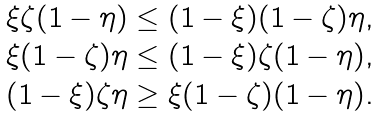Convert formula to latex. <formula><loc_0><loc_0><loc_500><loc_500>\begin{array} { l } \xi \zeta ( 1 - \eta ) \leq ( 1 - \xi ) ( 1 - \zeta ) \eta , \\ \xi ( 1 - \zeta ) \eta \leq ( 1 - \xi ) \zeta ( 1 - \eta ) , \\ ( 1 - \xi ) \zeta \eta \geq \xi ( 1 - \zeta ) ( 1 - \eta ) . \end{array}</formula> 